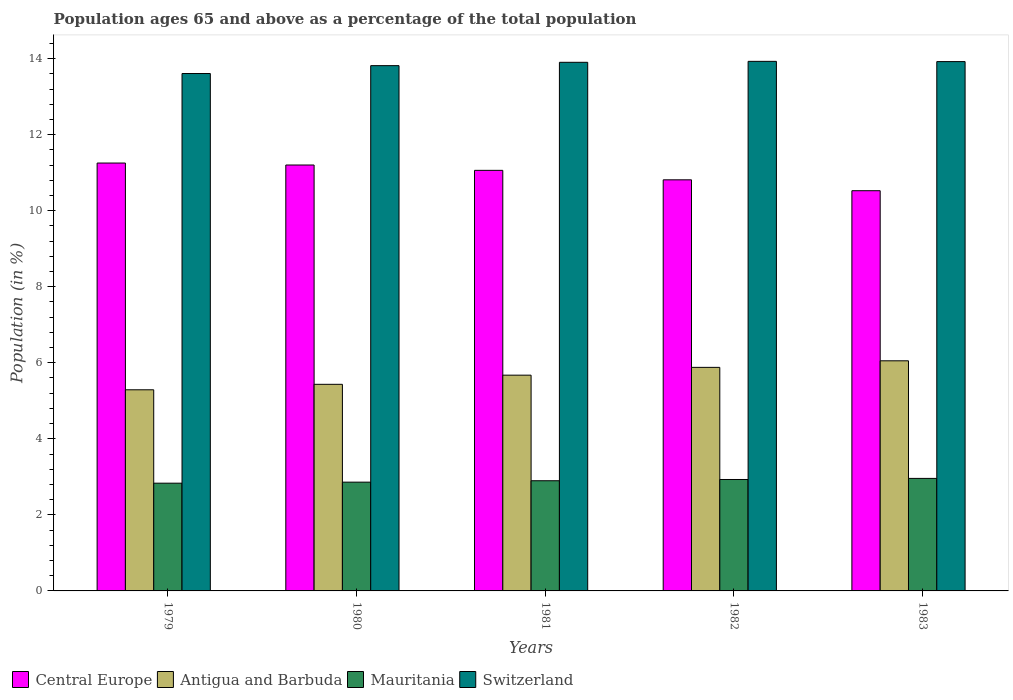How many groups of bars are there?
Provide a short and direct response. 5. Are the number of bars per tick equal to the number of legend labels?
Ensure brevity in your answer.  Yes. How many bars are there on the 5th tick from the left?
Make the answer very short. 4. How many bars are there on the 4th tick from the right?
Offer a very short reply. 4. In how many cases, is the number of bars for a given year not equal to the number of legend labels?
Your answer should be very brief. 0. What is the percentage of the population ages 65 and above in Central Europe in 1983?
Your answer should be very brief. 10.53. Across all years, what is the maximum percentage of the population ages 65 and above in Central Europe?
Keep it short and to the point. 11.25. Across all years, what is the minimum percentage of the population ages 65 and above in Central Europe?
Your response must be concise. 10.53. In which year was the percentage of the population ages 65 and above in Mauritania minimum?
Your answer should be very brief. 1979. What is the total percentage of the population ages 65 and above in Mauritania in the graph?
Keep it short and to the point. 14.48. What is the difference between the percentage of the population ages 65 and above in Mauritania in 1979 and that in 1982?
Your answer should be very brief. -0.1. What is the difference between the percentage of the population ages 65 and above in Antigua and Barbuda in 1981 and the percentage of the population ages 65 and above in Switzerland in 1979?
Ensure brevity in your answer.  -7.93. What is the average percentage of the population ages 65 and above in Central Europe per year?
Provide a succinct answer. 10.97. In the year 1981, what is the difference between the percentage of the population ages 65 and above in Central Europe and percentage of the population ages 65 and above in Switzerland?
Provide a short and direct response. -2.84. What is the ratio of the percentage of the population ages 65 and above in Mauritania in 1980 to that in 1982?
Keep it short and to the point. 0.98. Is the percentage of the population ages 65 and above in Mauritania in 1980 less than that in 1983?
Offer a very short reply. Yes. Is the difference between the percentage of the population ages 65 and above in Central Europe in 1979 and 1983 greater than the difference between the percentage of the population ages 65 and above in Switzerland in 1979 and 1983?
Keep it short and to the point. Yes. What is the difference between the highest and the second highest percentage of the population ages 65 and above in Switzerland?
Give a very brief answer. 0.01. What is the difference between the highest and the lowest percentage of the population ages 65 and above in Mauritania?
Offer a terse response. 0.13. What does the 3rd bar from the left in 1983 represents?
Ensure brevity in your answer.  Mauritania. What does the 2nd bar from the right in 1979 represents?
Provide a succinct answer. Mauritania. How many bars are there?
Offer a very short reply. 20. What is the difference between two consecutive major ticks on the Y-axis?
Ensure brevity in your answer.  2. Are the values on the major ticks of Y-axis written in scientific E-notation?
Make the answer very short. No. Does the graph contain any zero values?
Offer a terse response. No. Does the graph contain grids?
Provide a short and direct response. No. Where does the legend appear in the graph?
Your answer should be very brief. Bottom left. What is the title of the graph?
Keep it short and to the point. Population ages 65 and above as a percentage of the total population. Does "Kenya" appear as one of the legend labels in the graph?
Keep it short and to the point. No. What is the label or title of the X-axis?
Your response must be concise. Years. What is the label or title of the Y-axis?
Keep it short and to the point. Population (in %). What is the Population (in %) of Central Europe in 1979?
Provide a short and direct response. 11.25. What is the Population (in %) in Antigua and Barbuda in 1979?
Offer a terse response. 5.29. What is the Population (in %) of Mauritania in 1979?
Provide a succinct answer. 2.83. What is the Population (in %) of Switzerland in 1979?
Provide a short and direct response. 13.61. What is the Population (in %) of Central Europe in 1980?
Give a very brief answer. 11.2. What is the Population (in %) in Antigua and Barbuda in 1980?
Offer a very short reply. 5.43. What is the Population (in %) in Mauritania in 1980?
Keep it short and to the point. 2.86. What is the Population (in %) in Switzerland in 1980?
Give a very brief answer. 13.81. What is the Population (in %) of Central Europe in 1981?
Your answer should be very brief. 11.06. What is the Population (in %) of Antigua and Barbuda in 1981?
Offer a terse response. 5.67. What is the Population (in %) of Mauritania in 1981?
Provide a succinct answer. 2.9. What is the Population (in %) in Switzerland in 1981?
Your answer should be very brief. 13.9. What is the Population (in %) in Central Europe in 1982?
Provide a succinct answer. 10.81. What is the Population (in %) of Antigua and Barbuda in 1982?
Your response must be concise. 5.88. What is the Population (in %) of Mauritania in 1982?
Your response must be concise. 2.93. What is the Population (in %) of Switzerland in 1982?
Offer a very short reply. 13.93. What is the Population (in %) of Central Europe in 1983?
Your answer should be very brief. 10.53. What is the Population (in %) of Antigua and Barbuda in 1983?
Keep it short and to the point. 6.05. What is the Population (in %) of Mauritania in 1983?
Your answer should be compact. 2.96. What is the Population (in %) in Switzerland in 1983?
Your answer should be very brief. 13.92. Across all years, what is the maximum Population (in %) of Central Europe?
Ensure brevity in your answer.  11.25. Across all years, what is the maximum Population (in %) of Antigua and Barbuda?
Your answer should be compact. 6.05. Across all years, what is the maximum Population (in %) in Mauritania?
Give a very brief answer. 2.96. Across all years, what is the maximum Population (in %) of Switzerland?
Keep it short and to the point. 13.93. Across all years, what is the minimum Population (in %) of Central Europe?
Your answer should be very brief. 10.53. Across all years, what is the minimum Population (in %) in Antigua and Barbuda?
Your answer should be compact. 5.29. Across all years, what is the minimum Population (in %) of Mauritania?
Your answer should be compact. 2.83. Across all years, what is the minimum Population (in %) in Switzerland?
Your answer should be very brief. 13.61. What is the total Population (in %) in Central Europe in the graph?
Offer a very short reply. 54.85. What is the total Population (in %) of Antigua and Barbuda in the graph?
Your answer should be very brief. 28.33. What is the total Population (in %) of Mauritania in the graph?
Ensure brevity in your answer.  14.48. What is the total Population (in %) in Switzerland in the graph?
Offer a very short reply. 69.17. What is the difference between the Population (in %) of Central Europe in 1979 and that in 1980?
Provide a succinct answer. 0.05. What is the difference between the Population (in %) of Antigua and Barbuda in 1979 and that in 1980?
Your response must be concise. -0.14. What is the difference between the Population (in %) of Mauritania in 1979 and that in 1980?
Provide a short and direct response. -0.03. What is the difference between the Population (in %) in Switzerland in 1979 and that in 1980?
Ensure brevity in your answer.  -0.21. What is the difference between the Population (in %) of Central Europe in 1979 and that in 1981?
Keep it short and to the point. 0.19. What is the difference between the Population (in %) of Antigua and Barbuda in 1979 and that in 1981?
Your answer should be compact. -0.38. What is the difference between the Population (in %) in Mauritania in 1979 and that in 1981?
Make the answer very short. -0.06. What is the difference between the Population (in %) of Switzerland in 1979 and that in 1981?
Make the answer very short. -0.29. What is the difference between the Population (in %) in Central Europe in 1979 and that in 1982?
Offer a very short reply. 0.44. What is the difference between the Population (in %) in Antigua and Barbuda in 1979 and that in 1982?
Make the answer very short. -0.59. What is the difference between the Population (in %) of Mauritania in 1979 and that in 1982?
Provide a short and direct response. -0.1. What is the difference between the Population (in %) in Switzerland in 1979 and that in 1982?
Offer a very short reply. -0.32. What is the difference between the Population (in %) in Central Europe in 1979 and that in 1983?
Offer a very short reply. 0.73. What is the difference between the Population (in %) in Antigua and Barbuda in 1979 and that in 1983?
Provide a short and direct response. -0.76. What is the difference between the Population (in %) in Mauritania in 1979 and that in 1983?
Offer a very short reply. -0.13. What is the difference between the Population (in %) of Switzerland in 1979 and that in 1983?
Offer a very short reply. -0.31. What is the difference between the Population (in %) in Central Europe in 1980 and that in 1981?
Your answer should be compact. 0.14. What is the difference between the Population (in %) in Antigua and Barbuda in 1980 and that in 1981?
Offer a very short reply. -0.24. What is the difference between the Population (in %) of Mauritania in 1980 and that in 1981?
Provide a succinct answer. -0.04. What is the difference between the Population (in %) in Switzerland in 1980 and that in 1981?
Give a very brief answer. -0.09. What is the difference between the Population (in %) in Central Europe in 1980 and that in 1982?
Ensure brevity in your answer.  0.39. What is the difference between the Population (in %) in Antigua and Barbuda in 1980 and that in 1982?
Make the answer very short. -0.45. What is the difference between the Population (in %) in Mauritania in 1980 and that in 1982?
Ensure brevity in your answer.  -0.07. What is the difference between the Population (in %) in Switzerland in 1980 and that in 1982?
Keep it short and to the point. -0.11. What is the difference between the Population (in %) of Central Europe in 1980 and that in 1983?
Offer a very short reply. 0.68. What is the difference between the Population (in %) of Antigua and Barbuda in 1980 and that in 1983?
Offer a very short reply. -0.62. What is the difference between the Population (in %) in Mauritania in 1980 and that in 1983?
Give a very brief answer. -0.1. What is the difference between the Population (in %) of Switzerland in 1980 and that in 1983?
Provide a short and direct response. -0.11. What is the difference between the Population (in %) in Central Europe in 1981 and that in 1982?
Your answer should be very brief. 0.25. What is the difference between the Population (in %) in Antigua and Barbuda in 1981 and that in 1982?
Give a very brief answer. -0.21. What is the difference between the Population (in %) in Mauritania in 1981 and that in 1982?
Keep it short and to the point. -0.03. What is the difference between the Population (in %) in Switzerland in 1981 and that in 1982?
Provide a short and direct response. -0.03. What is the difference between the Population (in %) of Central Europe in 1981 and that in 1983?
Your answer should be very brief. 0.54. What is the difference between the Population (in %) in Antigua and Barbuda in 1981 and that in 1983?
Your response must be concise. -0.38. What is the difference between the Population (in %) of Mauritania in 1981 and that in 1983?
Ensure brevity in your answer.  -0.06. What is the difference between the Population (in %) in Switzerland in 1981 and that in 1983?
Give a very brief answer. -0.02. What is the difference between the Population (in %) of Central Europe in 1982 and that in 1983?
Your answer should be very brief. 0.29. What is the difference between the Population (in %) of Antigua and Barbuda in 1982 and that in 1983?
Your answer should be compact. -0.17. What is the difference between the Population (in %) of Mauritania in 1982 and that in 1983?
Provide a succinct answer. -0.03. What is the difference between the Population (in %) in Switzerland in 1982 and that in 1983?
Keep it short and to the point. 0.01. What is the difference between the Population (in %) in Central Europe in 1979 and the Population (in %) in Antigua and Barbuda in 1980?
Your answer should be compact. 5.82. What is the difference between the Population (in %) in Central Europe in 1979 and the Population (in %) in Mauritania in 1980?
Keep it short and to the point. 8.39. What is the difference between the Population (in %) of Central Europe in 1979 and the Population (in %) of Switzerland in 1980?
Offer a terse response. -2.56. What is the difference between the Population (in %) in Antigua and Barbuda in 1979 and the Population (in %) in Mauritania in 1980?
Provide a succinct answer. 2.43. What is the difference between the Population (in %) in Antigua and Barbuda in 1979 and the Population (in %) in Switzerland in 1980?
Your answer should be very brief. -8.53. What is the difference between the Population (in %) of Mauritania in 1979 and the Population (in %) of Switzerland in 1980?
Give a very brief answer. -10.98. What is the difference between the Population (in %) in Central Europe in 1979 and the Population (in %) in Antigua and Barbuda in 1981?
Give a very brief answer. 5.58. What is the difference between the Population (in %) of Central Europe in 1979 and the Population (in %) of Mauritania in 1981?
Your answer should be very brief. 8.36. What is the difference between the Population (in %) of Central Europe in 1979 and the Population (in %) of Switzerland in 1981?
Ensure brevity in your answer.  -2.65. What is the difference between the Population (in %) in Antigua and Barbuda in 1979 and the Population (in %) in Mauritania in 1981?
Your response must be concise. 2.39. What is the difference between the Population (in %) in Antigua and Barbuda in 1979 and the Population (in %) in Switzerland in 1981?
Your response must be concise. -8.61. What is the difference between the Population (in %) of Mauritania in 1979 and the Population (in %) of Switzerland in 1981?
Your answer should be very brief. -11.07. What is the difference between the Population (in %) of Central Europe in 1979 and the Population (in %) of Antigua and Barbuda in 1982?
Keep it short and to the point. 5.37. What is the difference between the Population (in %) in Central Europe in 1979 and the Population (in %) in Mauritania in 1982?
Your answer should be very brief. 8.32. What is the difference between the Population (in %) in Central Europe in 1979 and the Population (in %) in Switzerland in 1982?
Ensure brevity in your answer.  -2.67. What is the difference between the Population (in %) of Antigua and Barbuda in 1979 and the Population (in %) of Mauritania in 1982?
Offer a terse response. 2.36. What is the difference between the Population (in %) in Antigua and Barbuda in 1979 and the Population (in %) in Switzerland in 1982?
Provide a short and direct response. -8.64. What is the difference between the Population (in %) of Mauritania in 1979 and the Population (in %) of Switzerland in 1982?
Provide a succinct answer. -11.09. What is the difference between the Population (in %) of Central Europe in 1979 and the Population (in %) of Antigua and Barbuda in 1983?
Your answer should be very brief. 5.2. What is the difference between the Population (in %) in Central Europe in 1979 and the Population (in %) in Mauritania in 1983?
Your response must be concise. 8.29. What is the difference between the Population (in %) in Central Europe in 1979 and the Population (in %) in Switzerland in 1983?
Offer a very short reply. -2.67. What is the difference between the Population (in %) of Antigua and Barbuda in 1979 and the Population (in %) of Mauritania in 1983?
Ensure brevity in your answer.  2.33. What is the difference between the Population (in %) of Antigua and Barbuda in 1979 and the Population (in %) of Switzerland in 1983?
Keep it short and to the point. -8.63. What is the difference between the Population (in %) in Mauritania in 1979 and the Population (in %) in Switzerland in 1983?
Ensure brevity in your answer.  -11.09. What is the difference between the Population (in %) of Central Europe in 1980 and the Population (in %) of Antigua and Barbuda in 1981?
Make the answer very short. 5.53. What is the difference between the Population (in %) of Central Europe in 1980 and the Population (in %) of Mauritania in 1981?
Make the answer very short. 8.3. What is the difference between the Population (in %) in Central Europe in 1980 and the Population (in %) in Switzerland in 1981?
Give a very brief answer. -2.7. What is the difference between the Population (in %) of Antigua and Barbuda in 1980 and the Population (in %) of Mauritania in 1981?
Make the answer very short. 2.54. What is the difference between the Population (in %) in Antigua and Barbuda in 1980 and the Population (in %) in Switzerland in 1981?
Your answer should be compact. -8.47. What is the difference between the Population (in %) of Mauritania in 1980 and the Population (in %) of Switzerland in 1981?
Your answer should be compact. -11.04. What is the difference between the Population (in %) in Central Europe in 1980 and the Population (in %) in Antigua and Barbuda in 1982?
Your answer should be very brief. 5.32. What is the difference between the Population (in %) in Central Europe in 1980 and the Population (in %) in Mauritania in 1982?
Offer a very short reply. 8.27. What is the difference between the Population (in %) of Central Europe in 1980 and the Population (in %) of Switzerland in 1982?
Give a very brief answer. -2.73. What is the difference between the Population (in %) of Antigua and Barbuda in 1980 and the Population (in %) of Mauritania in 1982?
Provide a short and direct response. 2.5. What is the difference between the Population (in %) of Antigua and Barbuda in 1980 and the Population (in %) of Switzerland in 1982?
Offer a very short reply. -8.49. What is the difference between the Population (in %) of Mauritania in 1980 and the Population (in %) of Switzerland in 1982?
Offer a very short reply. -11.07. What is the difference between the Population (in %) in Central Europe in 1980 and the Population (in %) in Antigua and Barbuda in 1983?
Your answer should be compact. 5.15. What is the difference between the Population (in %) in Central Europe in 1980 and the Population (in %) in Mauritania in 1983?
Provide a short and direct response. 8.24. What is the difference between the Population (in %) of Central Europe in 1980 and the Population (in %) of Switzerland in 1983?
Offer a terse response. -2.72. What is the difference between the Population (in %) in Antigua and Barbuda in 1980 and the Population (in %) in Mauritania in 1983?
Give a very brief answer. 2.47. What is the difference between the Population (in %) of Antigua and Barbuda in 1980 and the Population (in %) of Switzerland in 1983?
Offer a terse response. -8.49. What is the difference between the Population (in %) of Mauritania in 1980 and the Population (in %) of Switzerland in 1983?
Your response must be concise. -11.06. What is the difference between the Population (in %) of Central Europe in 1981 and the Population (in %) of Antigua and Barbuda in 1982?
Provide a succinct answer. 5.18. What is the difference between the Population (in %) in Central Europe in 1981 and the Population (in %) in Mauritania in 1982?
Give a very brief answer. 8.13. What is the difference between the Population (in %) in Central Europe in 1981 and the Population (in %) in Switzerland in 1982?
Offer a very short reply. -2.87. What is the difference between the Population (in %) of Antigua and Barbuda in 1981 and the Population (in %) of Mauritania in 1982?
Offer a very short reply. 2.74. What is the difference between the Population (in %) of Antigua and Barbuda in 1981 and the Population (in %) of Switzerland in 1982?
Offer a very short reply. -8.25. What is the difference between the Population (in %) of Mauritania in 1981 and the Population (in %) of Switzerland in 1982?
Your response must be concise. -11.03. What is the difference between the Population (in %) in Central Europe in 1981 and the Population (in %) in Antigua and Barbuda in 1983?
Offer a very short reply. 5.01. What is the difference between the Population (in %) in Central Europe in 1981 and the Population (in %) in Mauritania in 1983?
Provide a succinct answer. 8.1. What is the difference between the Population (in %) of Central Europe in 1981 and the Population (in %) of Switzerland in 1983?
Give a very brief answer. -2.86. What is the difference between the Population (in %) of Antigua and Barbuda in 1981 and the Population (in %) of Mauritania in 1983?
Your answer should be compact. 2.72. What is the difference between the Population (in %) of Antigua and Barbuda in 1981 and the Population (in %) of Switzerland in 1983?
Make the answer very short. -8.25. What is the difference between the Population (in %) of Mauritania in 1981 and the Population (in %) of Switzerland in 1983?
Provide a short and direct response. -11.02. What is the difference between the Population (in %) in Central Europe in 1982 and the Population (in %) in Antigua and Barbuda in 1983?
Provide a short and direct response. 4.76. What is the difference between the Population (in %) in Central Europe in 1982 and the Population (in %) in Mauritania in 1983?
Make the answer very short. 7.85. What is the difference between the Population (in %) of Central Europe in 1982 and the Population (in %) of Switzerland in 1983?
Offer a very short reply. -3.11. What is the difference between the Population (in %) in Antigua and Barbuda in 1982 and the Population (in %) in Mauritania in 1983?
Ensure brevity in your answer.  2.92. What is the difference between the Population (in %) in Antigua and Barbuda in 1982 and the Population (in %) in Switzerland in 1983?
Make the answer very short. -8.04. What is the difference between the Population (in %) of Mauritania in 1982 and the Population (in %) of Switzerland in 1983?
Offer a very short reply. -10.99. What is the average Population (in %) in Central Europe per year?
Provide a succinct answer. 10.97. What is the average Population (in %) of Antigua and Barbuda per year?
Make the answer very short. 5.67. What is the average Population (in %) in Mauritania per year?
Provide a succinct answer. 2.9. What is the average Population (in %) of Switzerland per year?
Ensure brevity in your answer.  13.83. In the year 1979, what is the difference between the Population (in %) of Central Europe and Population (in %) of Antigua and Barbuda?
Give a very brief answer. 5.96. In the year 1979, what is the difference between the Population (in %) in Central Europe and Population (in %) in Mauritania?
Provide a short and direct response. 8.42. In the year 1979, what is the difference between the Population (in %) in Central Europe and Population (in %) in Switzerland?
Give a very brief answer. -2.35. In the year 1979, what is the difference between the Population (in %) of Antigua and Barbuda and Population (in %) of Mauritania?
Provide a short and direct response. 2.46. In the year 1979, what is the difference between the Population (in %) of Antigua and Barbuda and Population (in %) of Switzerland?
Ensure brevity in your answer.  -8.32. In the year 1979, what is the difference between the Population (in %) in Mauritania and Population (in %) in Switzerland?
Offer a very short reply. -10.77. In the year 1980, what is the difference between the Population (in %) of Central Europe and Population (in %) of Antigua and Barbuda?
Your answer should be compact. 5.77. In the year 1980, what is the difference between the Population (in %) of Central Europe and Population (in %) of Mauritania?
Your answer should be very brief. 8.34. In the year 1980, what is the difference between the Population (in %) in Central Europe and Population (in %) in Switzerland?
Keep it short and to the point. -2.61. In the year 1980, what is the difference between the Population (in %) of Antigua and Barbuda and Population (in %) of Mauritania?
Offer a terse response. 2.57. In the year 1980, what is the difference between the Population (in %) in Antigua and Barbuda and Population (in %) in Switzerland?
Offer a very short reply. -8.38. In the year 1980, what is the difference between the Population (in %) of Mauritania and Population (in %) of Switzerland?
Your response must be concise. -10.95. In the year 1981, what is the difference between the Population (in %) in Central Europe and Population (in %) in Antigua and Barbuda?
Provide a succinct answer. 5.39. In the year 1981, what is the difference between the Population (in %) in Central Europe and Population (in %) in Mauritania?
Offer a terse response. 8.16. In the year 1981, what is the difference between the Population (in %) of Central Europe and Population (in %) of Switzerland?
Offer a terse response. -2.84. In the year 1981, what is the difference between the Population (in %) in Antigua and Barbuda and Population (in %) in Mauritania?
Offer a very short reply. 2.78. In the year 1981, what is the difference between the Population (in %) of Antigua and Barbuda and Population (in %) of Switzerland?
Your answer should be very brief. -8.23. In the year 1981, what is the difference between the Population (in %) in Mauritania and Population (in %) in Switzerland?
Provide a succinct answer. -11. In the year 1982, what is the difference between the Population (in %) of Central Europe and Population (in %) of Antigua and Barbuda?
Provide a succinct answer. 4.93. In the year 1982, what is the difference between the Population (in %) in Central Europe and Population (in %) in Mauritania?
Provide a succinct answer. 7.88. In the year 1982, what is the difference between the Population (in %) of Central Europe and Population (in %) of Switzerland?
Ensure brevity in your answer.  -3.12. In the year 1982, what is the difference between the Population (in %) in Antigua and Barbuda and Population (in %) in Mauritania?
Give a very brief answer. 2.95. In the year 1982, what is the difference between the Population (in %) in Antigua and Barbuda and Population (in %) in Switzerland?
Provide a succinct answer. -8.05. In the year 1982, what is the difference between the Population (in %) of Mauritania and Population (in %) of Switzerland?
Provide a succinct answer. -11. In the year 1983, what is the difference between the Population (in %) in Central Europe and Population (in %) in Antigua and Barbuda?
Your answer should be very brief. 4.47. In the year 1983, what is the difference between the Population (in %) of Central Europe and Population (in %) of Mauritania?
Your answer should be compact. 7.57. In the year 1983, what is the difference between the Population (in %) in Central Europe and Population (in %) in Switzerland?
Your answer should be very brief. -3.4. In the year 1983, what is the difference between the Population (in %) in Antigua and Barbuda and Population (in %) in Mauritania?
Your answer should be very brief. 3.09. In the year 1983, what is the difference between the Population (in %) of Antigua and Barbuda and Population (in %) of Switzerland?
Offer a terse response. -7.87. In the year 1983, what is the difference between the Population (in %) of Mauritania and Population (in %) of Switzerland?
Give a very brief answer. -10.96. What is the ratio of the Population (in %) of Antigua and Barbuda in 1979 to that in 1980?
Provide a short and direct response. 0.97. What is the ratio of the Population (in %) of Switzerland in 1979 to that in 1980?
Provide a succinct answer. 0.98. What is the ratio of the Population (in %) in Central Europe in 1979 to that in 1981?
Your response must be concise. 1.02. What is the ratio of the Population (in %) in Antigua and Barbuda in 1979 to that in 1981?
Offer a terse response. 0.93. What is the ratio of the Population (in %) of Mauritania in 1979 to that in 1981?
Provide a short and direct response. 0.98. What is the ratio of the Population (in %) of Switzerland in 1979 to that in 1981?
Make the answer very short. 0.98. What is the ratio of the Population (in %) of Central Europe in 1979 to that in 1982?
Your response must be concise. 1.04. What is the ratio of the Population (in %) of Antigua and Barbuda in 1979 to that in 1982?
Ensure brevity in your answer.  0.9. What is the ratio of the Population (in %) in Mauritania in 1979 to that in 1982?
Give a very brief answer. 0.97. What is the ratio of the Population (in %) of Central Europe in 1979 to that in 1983?
Give a very brief answer. 1.07. What is the ratio of the Population (in %) of Antigua and Barbuda in 1979 to that in 1983?
Provide a short and direct response. 0.87. What is the ratio of the Population (in %) of Mauritania in 1979 to that in 1983?
Make the answer very short. 0.96. What is the ratio of the Population (in %) of Switzerland in 1979 to that in 1983?
Ensure brevity in your answer.  0.98. What is the ratio of the Population (in %) in Central Europe in 1980 to that in 1981?
Keep it short and to the point. 1.01. What is the ratio of the Population (in %) in Antigua and Barbuda in 1980 to that in 1981?
Keep it short and to the point. 0.96. What is the ratio of the Population (in %) of Mauritania in 1980 to that in 1981?
Provide a succinct answer. 0.99. What is the ratio of the Population (in %) in Central Europe in 1980 to that in 1982?
Your answer should be very brief. 1.04. What is the ratio of the Population (in %) of Antigua and Barbuda in 1980 to that in 1982?
Provide a succinct answer. 0.92. What is the ratio of the Population (in %) of Mauritania in 1980 to that in 1982?
Your answer should be compact. 0.98. What is the ratio of the Population (in %) in Switzerland in 1980 to that in 1982?
Make the answer very short. 0.99. What is the ratio of the Population (in %) in Central Europe in 1980 to that in 1983?
Your answer should be compact. 1.06. What is the ratio of the Population (in %) of Antigua and Barbuda in 1980 to that in 1983?
Make the answer very short. 0.9. What is the ratio of the Population (in %) in Mauritania in 1980 to that in 1983?
Offer a terse response. 0.97. What is the ratio of the Population (in %) of Central Europe in 1981 to that in 1982?
Give a very brief answer. 1.02. What is the ratio of the Population (in %) of Antigua and Barbuda in 1981 to that in 1982?
Keep it short and to the point. 0.97. What is the ratio of the Population (in %) of Mauritania in 1981 to that in 1982?
Your response must be concise. 0.99. What is the ratio of the Population (in %) of Central Europe in 1981 to that in 1983?
Ensure brevity in your answer.  1.05. What is the ratio of the Population (in %) of Antigua and Barbuda in 1981 to that in 1983?
Provide a short and direct response. 0.94. What is the ratio of the Population (in %) in Mauritania in 1981 to that in 1983?
Keep it short and to the point. 0.98. What is the ratio of the Population (in %) in Central Europe in 1982 to that in 1983?
Your answer should be compact. 1.03. What is the ratio of the Population (in %) of Antigua and Barbuda in 1982 to that in 1983?
Offer a very short reply. 0.97. What is the ratio of the Population (in %) of Mauritania in 1982 to that in 1983?
Give a very brief answer. 0.99. What is the difference between the highest and the second highest Population (in %) of Central Europe?
Your answer should be compact. 0.05. What is the difference between the highest and the second highest Population (in %) of Antigua and Barbuda?
Offer a terse response. 0.17. What is the difference between the highest and the second highest Population (in %) of Mauritania?
Ensure brevity in your answer.  0.03. What is the difference between the highest and the second highest Population (in %) of Switzerland?
Give a very brief answer. 0.01. What is the difference between the highest and the lowest Population (in %) of Central Europe?
Keep it short and to the point. 0.73. What is the difference between the highest and the lowest Population (in %) in Antigua and Barbuda?
Keep it short and to the point. 0.76. What is the difference between the highest and the lowest Population (in %) of Mauritania?
Give a very brief answer. 0.13. What is the difference between the highest and the lowest Population (in %) in Switzerland?
Keep it short and to the point. 0.32. 